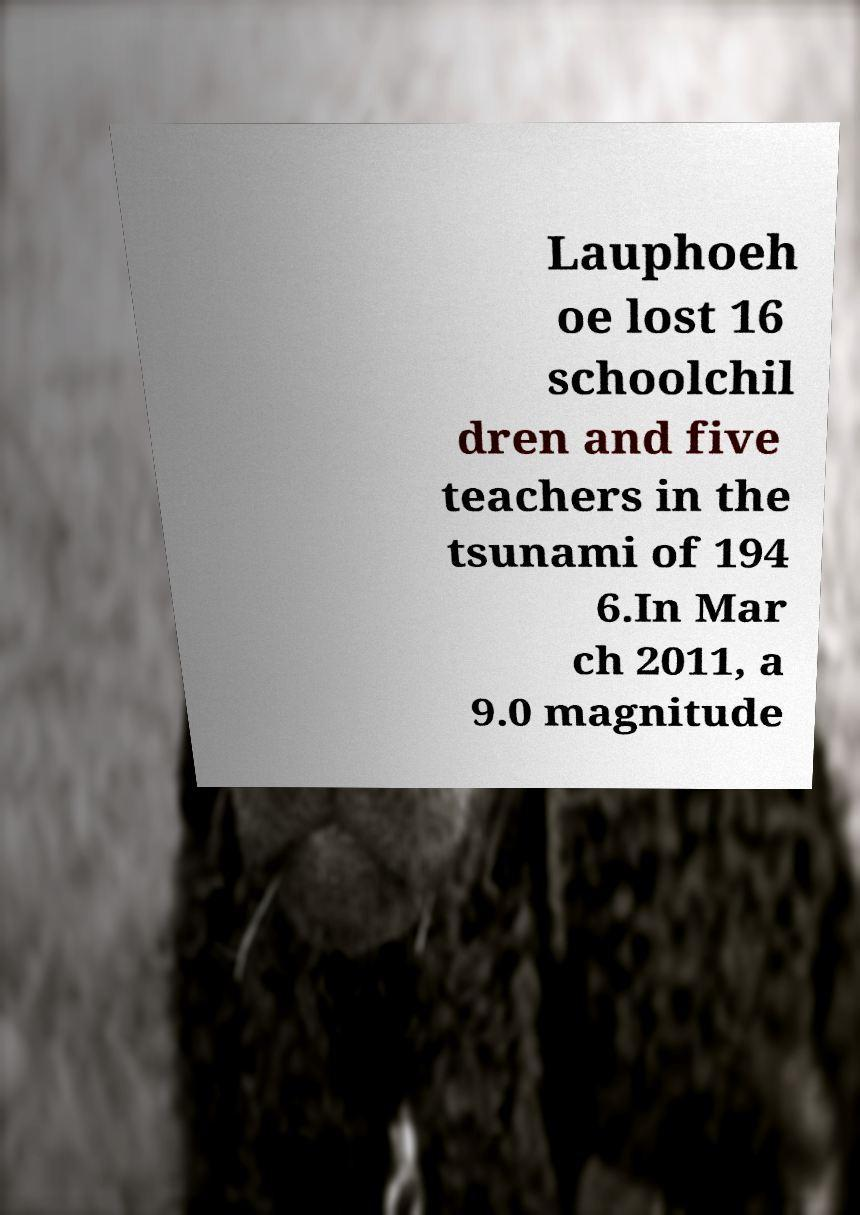Could you extract and type out the text from this image? Lauphoeh oe lost 16 schoolchil dren and five teachers in the tsunami of 194 6.In Mar ch 2011, a 9.0 magnitude 